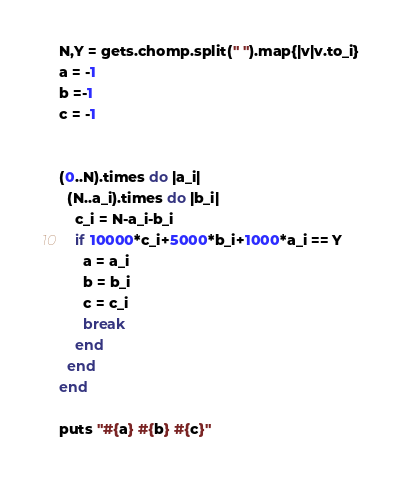<code> <loc_0><loc_0><loc_500><loc_500><_Ruby_>N,Y = gets.chomp.split(" ").map{|v|v.to_i}
a = -1
b =-1
c = -1


(0..N).times do |a_i|
  (N..a_i).times do |b_i|
    c_i = N-a_i-b_i
    if 10000*c_i+5000*b_i+1000*a_i == Y 
      a = a_i
      b = b_i
      c = c_i
      break
    end
  end
end

puts "#{a} #{b} #{c}"
</code> 